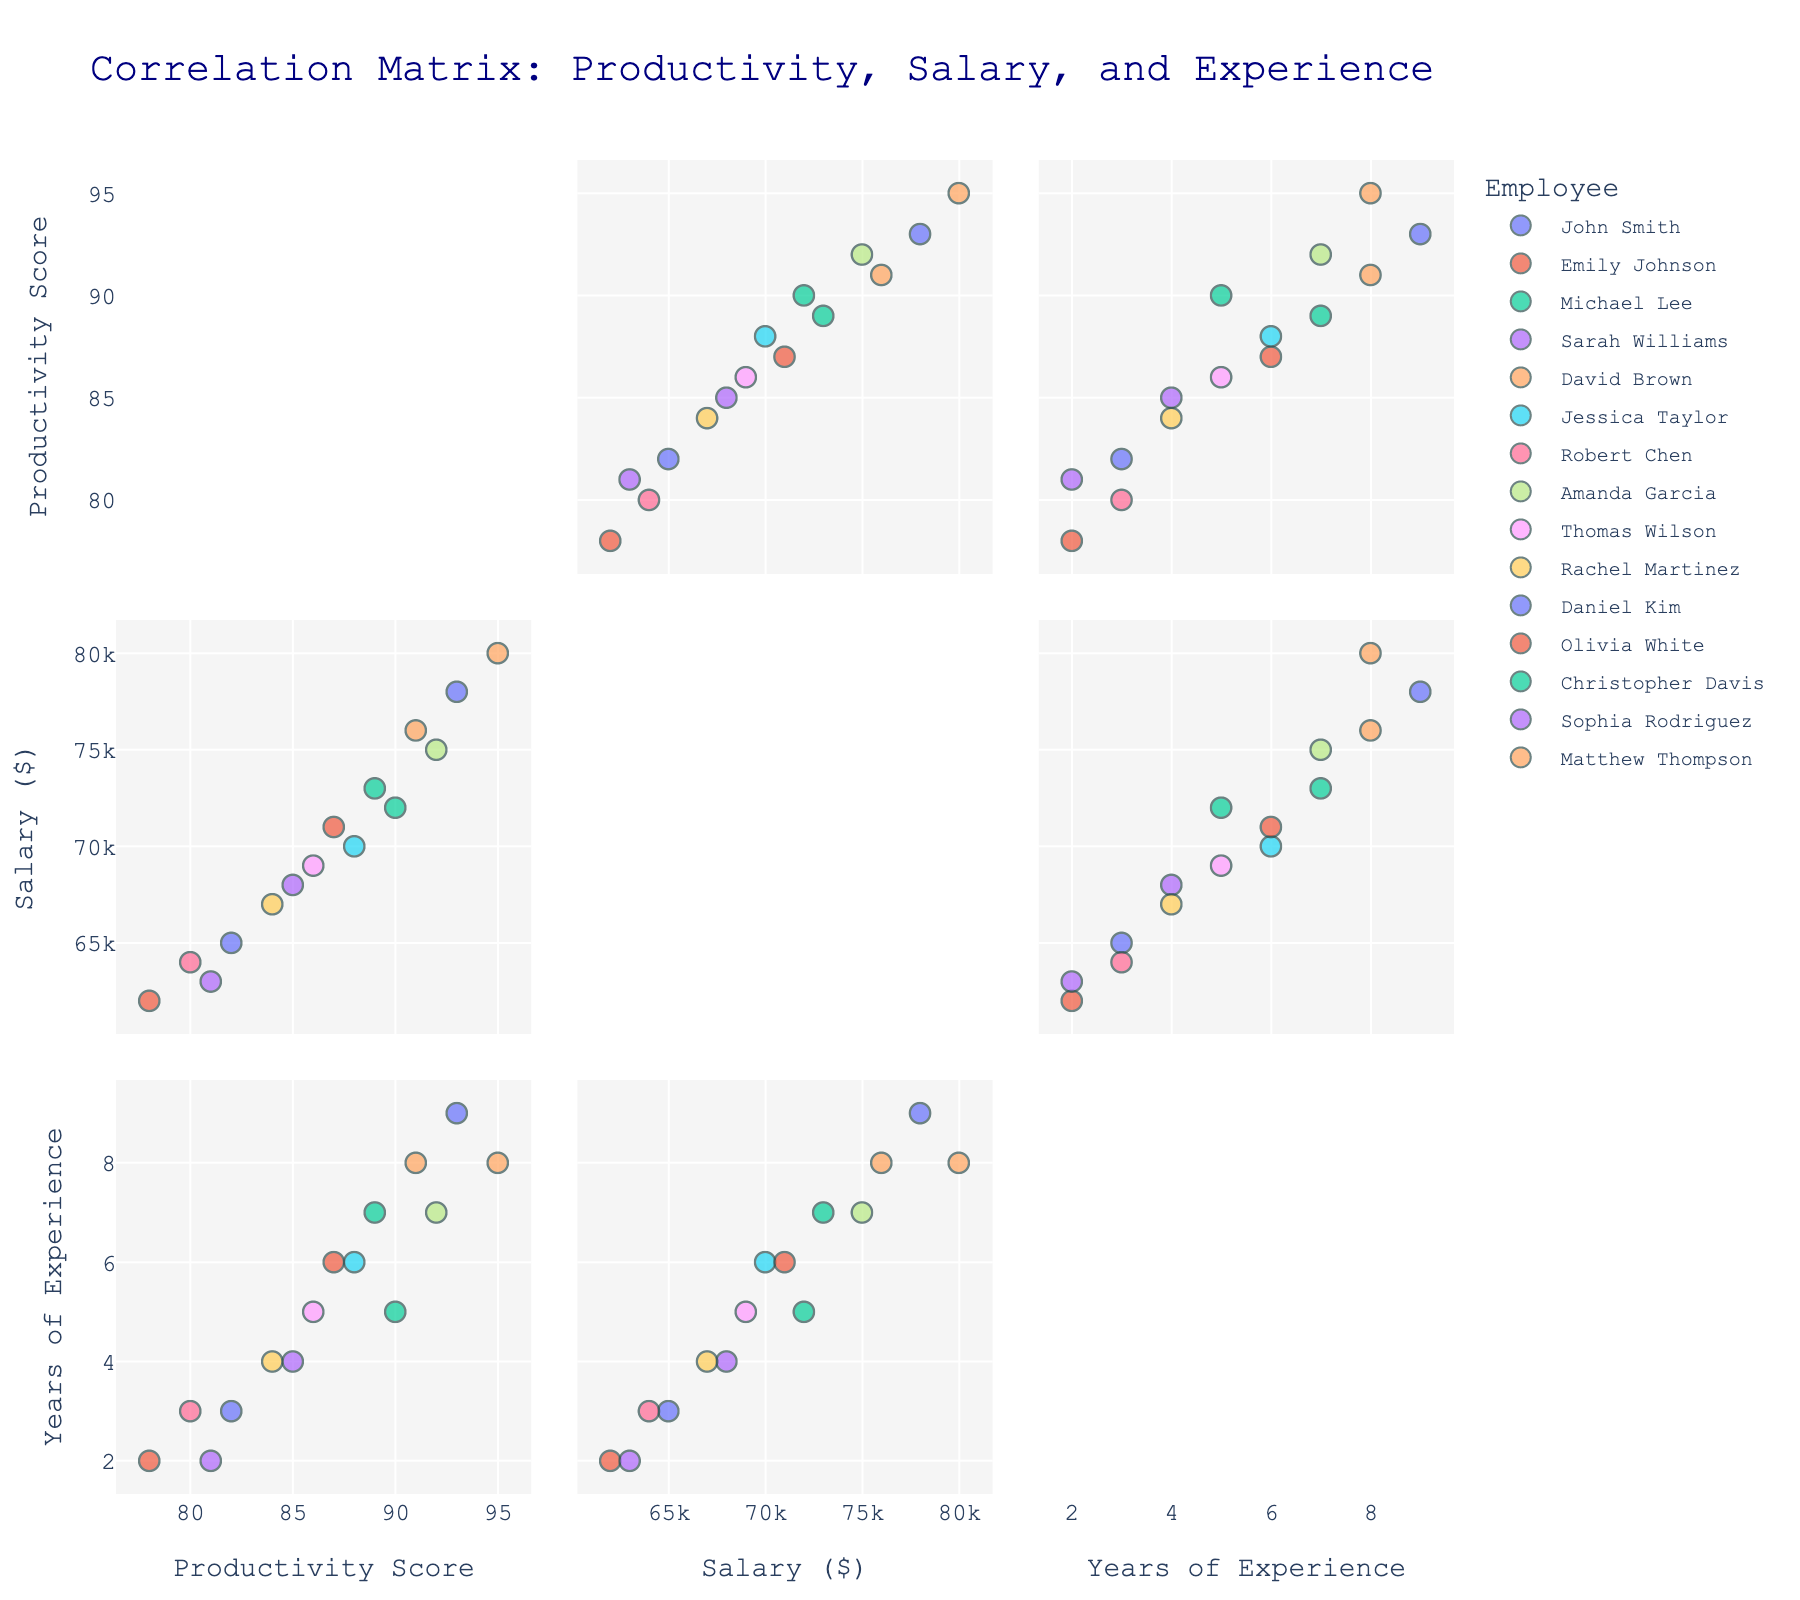What is the title of the scatterplot matrix? The title is typically located at the top of the scatterplot matrix and is usually larger and bolder compared to other text.
Answer: Correlation Matrix: Productivity, Salary, and Experience What variables are compared in the scatterplot matrix? To identify the variables compared, locate the labels on the axes of the scatterplot matrix.
Answer: Productivity, Salary, Experience How many employees are represented in the scatterplot matrix? Count the number of unique colors or legends representing different employees.
Answer: 15 What is the range of salaries presented in the scatterplot matrix? Check the axis labeled 'Salary ($)' to find the minimum and maximum values.
Answer: $62,000 to $80,000 Do more experienced employees tend to have higher salaries? Look at the trend or patterns in the scatterplot where Experience is on one axis and Salary is on another axis to see if higher Experience often occurs with higher Salary.
Answer: Yes How does the productivity score correlate with years of experience? Examine the scatterplot where Productivity is on one axis and Experience is on another axis, looking at the direction and tightness of the points' distribution.
Answer: Generally positive Which employee has the highest productivity score and what is that score? Identify the highest point on the Productivity axis and cross-reference with the legend for employee name.
Answer: David Brown, 95 Compare the salaries of the least experienced employee and the most experienced employee. What do you observe? Locate the least experienced (2 years) and most experienced (9 years) data points, then compare their Salary values.
Answer: The most experienced (Daniel Kim, $78,000) earns more than the least experienced (Sophia Rodriguez, $63,000) What is the relationship between salary and productivity? Look at the scatterplot where Salary is on one axis and Productivity is on another axis, and observe the overall trend of the data points.
Answer: Positive correlation Are there any outliers in terms of productivity score? If so, which employee(s)? Look for any data points that are significantly detached from the cluster of other points in the scatterplot for Productivity.
Answer: Possibly David Brown (95) 